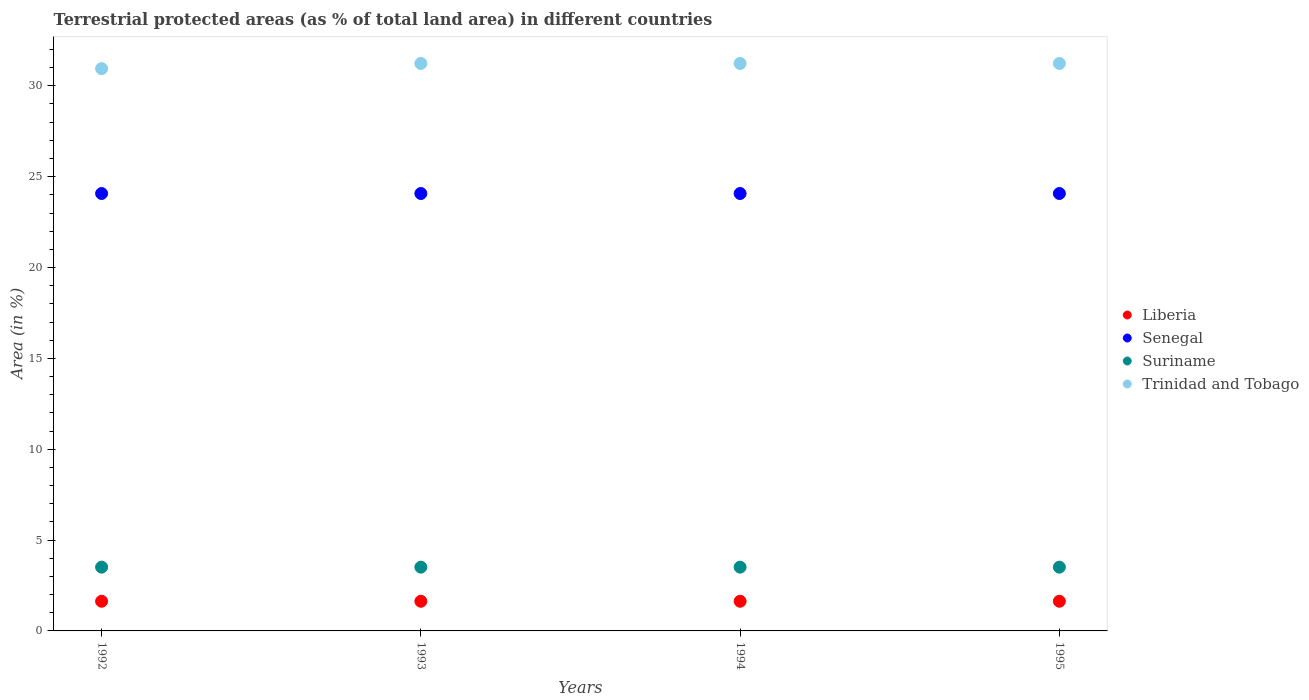How many different coloured dotlines are there?
Ensure brevity in your answer.  4. What is the percentage of terrestrial protected land in Suriname in 1993?
Your answer should be compact. 3.51. Across all years, what is the maximum percentage of terrestrial protected land in Suriname?
Offer a terse response. 3.51. Across all years, what is the minimum percentage of terrestrial protected land in Trinidad and Tobago?
Provide a succinct answer. 30.94. In which year was the percentage of terrestrial protected land in Trinidad and Tobago maximum?
Provide a short and direct response. 1993. In which year was the percentage of terrestrial protected land in Senegal minimum?
Your response must be concise. 1992. What is the total percentage of terrestrial protected land in Suriname in the graph?
Your response must be concise. 14.04. What is the difference between the percentage of terrestrial protected land in Trinidad and Tobago in 1992 and that in 1994?
Provide a short and direct response. -0.29. What is the difference between the percentage of terrestrial protected land in Liberia in 1994 and the percentage of terrestrial protected land in Trinidad and Tobago in 1992?
Offer a terse response. -29.31. What is the average percentage of terrestrial protected land in Senegal per year?
Keep it short and to the point. 24.07. In the year 1993, what is the difference between the percentage of terrestrial protected land in Senegal and percentage of terrestrial protected land in Trinidad and Tobago?
Offer a terse response. -7.16. In how many years, is the percentage of terrestrial protected land in Liberia greater than 13 %?
Provide a short and direct response. 0. Is the percentage of terrestrial protected land in Trinidad and Tobago in 1993 less than that in 1994?
Give a very brief answer. No. What is the difference between the highest and the lowest percentage of terrestrial protected land in Trinidad and Tobago?
Provide a succinct answer. 0.29. In how many years, is the percentage of terrestrial protected land in Senegal greater than the average percentage of terrestrial protected land in Senegal taken over all years?
Make the answer very short. 0. Is it the case that in every year, the sum of the percentage of terrestrial protected land in Senegal and percentage of terrestrial protected land in Suriname  is greater than the sum of percentage of terrestrial protected land in Liberia and percentage of terrestrial protected land in Trinidad and Tobago?
Your response must be concise. No. Does the percentage of terrestrial protected land in Suriname monotonically increase over the years?
Provide a succinct answer. No. Are the values on the major ticks of Y-axis written in scientific E-notation?
Give a very brief answer. No. Does the graph contain any zero values?
Your response must be concise. No. Does the graph contain grids?
Give a very brief answer. No. Where does the legend appear in the graph?
Your answer should be very brief. Center right. What is the title of the graph?
Provide a succinct answer. Terrestrial protected areas (as % of total land area) in different countries. Does "Hong Kong" appear as one of the legend labels in the graph?
Your answer should be compact. No. What is the label or title of the Y-axis?
Ensure brevity in your answer.  Area (in %). What is the Area (in %) in Liberia in 1992?
Your answer should be compact. 1.63. What is the Area (in %) of Senegal in 1992?
Offer a terse response. 24.07. What is the Area (in %) in Suriname in 1992?
Your answer should be compact. 3.51. What is the Area (in %) of Trinidad and Tobago in 1992?
Keep it short and to the point. 30.94. What is the Area (in %) in Liberia in 1993?
Your response must be concise. 1.63. What is the Area (in %) of Senegal in 1993?
Offer a very short reply. 24.07. What is the Area (in %) in Suriname in 1993?
Make the answer very short. 3.51. What is the Area (in %) of Trinidad and Tobago in 1993?
Your response must be concise. 31.23. What is the Area (in %) of Liberia in 1994?
Give a very brief answer. 1.63. What is the Area (in %) of Senegal in 1994?
Provide a succinct answer. 24.07. What is the Area (in %) in Suriname in 1994?
Give a very brief answer. 3.51. What is the Area (in %) of Trinidad and Tobago in 1994?
Keep it short and to the point. 31.23. What is the Area (in %) in Liberia in 1995?
Give a very brief answer. 1.63. What is the Area (in %) of Senegal in 1995?
Offer a terse response. 24.07. What is the Area (in %) of Suriname in 1995?
Give a very brief answer. 3.51. What is the Area (in %) in Trinidad and Tobago in 1995?
Your response must be concise. 31.23. Across all years, what is the maximum Area (in %) in Liberia?
Offer a terse response. 1.63. Across all years, what is the maximum Area (in %) in Senegal?
Ensure brevity in your answer.  24.07. Across all years, what is the maximum Area (in %) of Suriname?
Your answer should be compact. 3.51. Across all years, what is the maximum Area (in %) in Trinidad and Tobago?
Ensure brevity in your answer.  31.23. Across all years, what is the minimum Area (in %) of Liberia?
Give a very brief answer. 1.63. Across all years, what is the minimum Area (in %) in Senegal?
Your response must be concise. 24.07. Across all years, what is the minimum Area (in %) of Suriname?
Provide a succinct answer. 3.51. Across all years, what is the minimum Area (in %) of Trinidad and Tobago?
Offer a terse response. 30.94. What is the total Area (in %) in Liberia in the graph?
Keep it short and to the point. 6.53. What is the total Area (in %) of Senegal in the graph?
Your answer should be compact. 96.3. What is the total Area (in %) of Suriname in the graph?
Make the answer very short. 14.04. What is the total Area (in %) in Trinidad and Tobago in the graph?
Offer a terse response. 124.64. What is the difference between the Area (in %) in Liberia in 1992 and that in 1993?
Your answer should be very brief. 0. What is the difference between the Area (in %) of Senegal in 1992 and that in 1993?
Provide a short and direct response. 0. What is the difference between the Area (in %) in Suriname in 1992 and that in 1993?
Offer a terse response. 0. What is the difference between the Area (in %) in Trinidad and Tobago in 1992 and that in 1993?
Keep it short and to the point. -0.29. What is the difference between the Area (in %) of Senegal in 1992 and that in 1994?
Keep it short and to the point. 0. What is the difference between the Area (in %) of Suriname in 1992 and that in 1994?
Your response must be concise. 0. What is the difference between the Area (in %) of Trinidad and Tobago in 1992 and that in 1994?
Provide a succinct answer. -0.29. What is the difference between the Area (in %) in Liberia in 1992 and that in 1995?
Ensure brevity in your answer.  0. What is the difference between the Area (in %) of Suriname in 1992 and that in 1995?
Provide a short and direct response. 0. What is the difference between the Area (in %) of Trinidad and Tobago in 1992 and that in 1995?
Keep it short and to the point. -0.29. What is the difference between the Area (in %) of Liberia in 1993 and that in 1994?
Provide a succinct answer. 0. What is the difference between the Area (in %) in Suriname in 1993 and that in 1994?
Provide a succinct answer. 0. What is the difference between the Area (in %) of Suriname in 1993 and that in 1995?
Give a very brief answer. 0. What is the difference between the Area (in %) of Suriname in 1994 and that in 1995?
Offer a very short reply. 0. What is the difference between the Area (in %) of Trinidad and Tobago in 1994 and that in 1995?
Offer a terse response. 0. What is the difference between the Area (in %) of Liberia in 1992 and the Area (in %) of Senegal in 1993?
Provide a short and direct response. -22.44. What is the difference between the Area (in %) of Liberia in 1992 and the Area (in %) of Suriname in 1993?
Make the answer very short. -1.88. What is the difference between the Area (in %) of Liberia in 1992 and the Area (in %) of Trinidad and Tobago in 1993?
Offer a very short reply. -29.6. What is the difference between the Area (in %) of Senegal in 1992 and the Area (in %) of Suriname in 1993?
Make the answer very short. 20.56. What is the difference between the Area (in %) of Senegal in 1992 and the Area (in %) of Trinidad and Tobago in 1993?
Make the answer very short. -7.16. What is the difference between the Area (in %) in Suriname in 1992 and the Area (in %) in Trinidad and Tobago in 1993?
Your answer should be very brief. -27.72. What is the difference between the Area (in %) in Liberia in 1992 and the Area (in %) in Senegal in 1994?
Provide a short and direct response. -22.44. What is the difference between the Area (in %) in Liberia in 1992 and the Area (in %) in Suriname in 1994?
Provide a succinct answer. -1.88. What is the difference between the Area (in %) of Liberia in 1992 and the Area (in %) of Trinidad and Tobago in 1994?
Ensure brevity in your answer.  -29.6. What is the difference between the Area (in %) of Senegal in 1992 and the Area (in %) of Suriname in 1994?
Offer a terse response. 20.56. What is the difference between the Area (in %) in Senegal in 1992 and the Area (in %) in Trinidad and Tobago in 1994?
Keep it short and to the point. -7.16. What is the difference between the Area (in %) of Suriname in 1992 and the Area (in %) of Trinidad and Tobago in 1994?
Offer a very short reply. -27.72. What is the difference between the Area (in %) of Liberia in 1992 and the Area (in %) of Senegal in 1995?
Offer a terse response. -22.44. What is the difference between the Area (in %) in Liberia in 1992 and the Area (in %) in Suriname in 1995?
Your response must be concise. -1.88. What is the difference between the Area (in %) in Liberia in 1992 and the Area (in %) in Trinidad and Tobago in 1995?
Offer a terse response. -29.6. What is the difference between the Area (in %) in Senegal in 1992 and the Area (in %) in Suriname in 1995?
Give a very brief answer. 20.56. What is the difference between the Area (in %) of Senegal in 1992 and the Area (in %) of Trinidad and Tobago in 1995?
Your response must be concise. -7.16. What is the difference between the Area (in %) in Suriname in 1992 and the Area (in %) in Trinidad and Tobago in 1995?
Keep it short and to the point. -27.72. What is the difference between the Area (in %) of Liberia in 1993 and the Area (in %) of Senegal in 1994?
Offer a very short reply. -22.44. What is the difference between the Area (in %) in Liberia in 1993 and the Area (in %) in Suriname in 1994?
Offer a very short reply. -1.88. What is the difference between the Area (in %) in Liberia in 1993 and the Area (in %) in Trinidad and Tobago in 1994?
Give a very brief answer. -29.6. What is the difference between the Area (in %) of Senegal in 1993 and the Area (in %) of Suriname in 1994?
Your response must be concise. 20.56. What is the difference between the Area (in %) of Senegal in 1993 and the Area (in %) of Trinidad and Tobago in 1994?
Keep it short and to the point. -7.16. What is the difference between the Area (in %) in Suriname in 1993 and the Area (in %) in Trinidad and Tobago in 1994?
Your answer should be compact. -27.72. What is the difference between the Area (in %) in Liberia in 1993 and the Area (in %) in Senegal in 1995?
Offer a terse response. -22.44. What is the difference between the Area (in %) of Liberia in 1993 and the Area (in %) of Suriname in 1995?
Offer a terse response. -1.88. What is the difference between the Area (in %) of Liberia in 1993 and the Area (in %) of Trinidad and Tobago in 1995?
Make the answer very short. -29.6. What is the difference between the Area (in %) in Senegal in 1993 and the Area (in %) in Suriname in 1995?
Keep it short and to the point. 20.56. What is the difference between the Area (in %) in Senegal in 1993 and the Area (in %) in Trinidad and Tobago in 1995?
Provide a short and direct response. -7.16. What is the difference between the Area (in %) of Suriname in 1993 and the Area (in %) of Trinidad and Tobago in 1995?
Keep it short and to the point. -27.72. What is the difference between the Area (in %) in Liberia in 1994 and the Area (in %) in Senegal in 1995?
Your answer should be compact. -22.44. What is the difference between the Area (in %) in Liberia in 1994 and the Area (in %) in Suriname in 1995?
Your answer should be very brief. -1.88. What is the difference between the Area (in %) in Liberia in 1994 and the Area (in %) in Trinidad and Tobago in 1995?
Provide a short and direct response. -29.6. What is the difference between the Area (in %) of Senegal in 1994 and the Area (in %) of Suriname in 1995?
Your response must be concise. 20.56. What is the difference between the Area (in %) in Senegal in 1994 and the Area (in %) in Trinidad and Tobago in 1995?
Make the answer very short. -7.16. What is the difference between the Area (in %) in Suriname in 1994 and the Area (in %) in Trinidad and Tobago in 1995?
Keep it short and to the point. -27.72. What is the average Area (in %) in Liberia per year?
Your answer should be very brief. 1.63. What is the average Area (in %) in Senegal per year?
Your response must be concise. 24.07. What is the average Area (in %) of Suriname per year?
Offer a terse response. 3.51. What is the average Area (in %) in Trinidad and Tobago per year?
Ensure brevity in your answer.  31.16. In the year 1992, what is the difference between the Area (in %) in Liberia and Area (in %) in Senegal?
Provide a succinct answer. -22.44. In the year 1992, what is the difference between the Area (in %) of Liberia and Area (in %) of Suriname?
Your answer should be compact. -1.88. In the year 1992, what is the difference between the Area (in %) in Liberia and Area (in %) in Trinidad and Tobago?
Your answer should be very brief. -29.31. In the year 1992, what is the difference between the Area (in %) of Senegal and Area (in %) of Suriname?
Your answer should be very brief. 20.56. In the year 1992, what is the difference between the Area (in %) in Senegal and Area (in %) in Trinidad and Tobago?
Your response must be concise. -6.87. In the year 1992, what is the difference between the Area (in %) in Suriname and Area (in %) in Trinidad and Tobago?
Offer a very short reply. -27.43. In the year 1993, what is the difference between the Area (in %) in Liberia and Area (in %) in Senegal?
Keep it short and to the point. -22.44. In the year 1993, what is the difference between the Area (in %) of Liberia and Area (in %) of Suriname?
Offer a very short reply. -1.88. In the year 1993, what is the difference between the Area (in %) of Liberia and Area (in %) of Trinidad and Tobago?
Provide a short and direct response. -29.6. In the year 1993, what is the difference between the Area (in %) of Senegal and Area (in %) of Suriname?
Ensure brevity in your answer.  20.56. In the year 1993, what is the difference between the Area (in %) in Senegal and Area (in %) in Trinidad and Tobago?
Offer a terse response. -7.16. In the year 1993, what is the difference between the Area (in %) of Suriname and Area (in %) of Trinidad and Tobago?
Make the answer very short. -27.72. In the year 1994, what is the difference between the Area (in %) in Liberia and Area (in %) in Senegal?
Your answer should be very brief. -22.44. In the year 1994, what is the difference between the Area (in %) in Liberia and Area (in %) in Suriname?
Your response must be concise. -1.88. In the year 1994, what is the difference between the Area (in %) of Liberia and Area (in %) of Trinidad and Tobago?
Provide a succinct answer. -29.6. In the year 1994, what is the difference between the Area (in %) of Senegal and Area (in %) of Suriname?
Provide a short and direct response. 20.56. In the year 1994, what is the difference between the Area (in %) in Senegal and Area (in %) in Trinidad and Tobago?
Ensure brevity in your answer.  -7.16. In the year 1994, what is the difference between the Area (in %) of Suriname and Area (in %) of Trinidad and Tobago?
Provide a short and direct response. -27.72. In the year 1995, what is the difference between the Area (in %) in Liberia and Area (in %) in Senegal?
Offer a terse response. -22.44. In the year 1995, what is the difference between the Area (in %) in Liberia and Area (in %) in Suriname?
Give a very brief answer. -1.88. In the year 1995, what is the difference between the Area (in %) in Liberia and Area (in %) in Trinidad and Tobago?
Your answer should be very brief. -29.6. In the year 1995, what is the difference between the Area (in %) of Senegal and Area (in %) of Suriname?
Provide a short and direct response. 20.56. In the year 1995, what is the difference between the Area (in %) in Senegal and Area (in %) in Trinidad and Tobago?
Keep it short and to the point. -7.16. In the year 1995, what is the difference between the Area (in %) of Suriname and Area (in %) of Trinidad and Tobago?
Your answer should be compact. -27.72. What is the ratio of the Area (in %) in Liberia in 1992 to that in 1993?
Your response must be concise. 1. What is the ratio of the Area (in %) in Suriname in 1992 to that in 1993?
Your answer should be compact. 1. What is the ratio of the Area (in %) of Trinidad and Tobago in 1992 to that in 1993?
Provide a succinct answer. 0.99. What is the ratio of the Area (in %) in Suriname in 1992 to that in 1994?
Offer a very short reply. 1. What is the ratio of the Area (in %) of Trinidad and Tobago in 1992 to that in 1994?
Offer a terse response. 0.99. What is the ratio of the Area (in %) in Liberia in 1992 to that in 1995?
Your answer should be compact. 1. What is the ratio of the Area (in %) in Senegal in 1992 to that in 1995?
Offer a terse response. 1. What is the ratio of the Area (in %) in Trinidad and Tobago in 1992 to that in 1995?
Offer a terse response. 0.99. What is the ratio of the Area (in %) of Trinidad and Tobago in 1993 to that in 1994?
Your answer should be very brief. 1. What is the ratio of the Area (in %) of Liberia in 1993 to that in 1995?
Give a very brief answer. 1. What is the ratio of the Area (in %) in Senegal in 1993 to that in 1995?
Offer a terse response. 1. What is the ratio of the Area (in %) in Suriname in 1993 to that in 1995?
Give a very brief answer. 1. What is the ratio of the Area (in %) of Senegal in 1994 to that in 1995?
Your answer should be very brief. 1. What is the ratio of the Area (in %) of Suriname in 1994 to that in 1995?
Provide a succinct answer. 1. What is the ratio of the Area (in %) in Trinidad and Tobago in 1994 to that in 1995?
Provide a succinct answer. 1. What is the difference between the highest and the second highest Area (in %) in Suriname?
Make the answer very short. 0. What is the difference between the highest and the lowest Area (in %) in Liberia?
Keep it short and to the point. 0. What is the difference between the highest and the lowest Area (in %) in Senegal?
Keep it short and to the point. 0. What is the difference between the highest and the lowest Area (in %) of Suriname?
Ensure brevity in your answer.  0. What is the difference between the highest and the lowest Area (in %) of Trinidad and Tobago?
Offer a terse response. 0.29. 